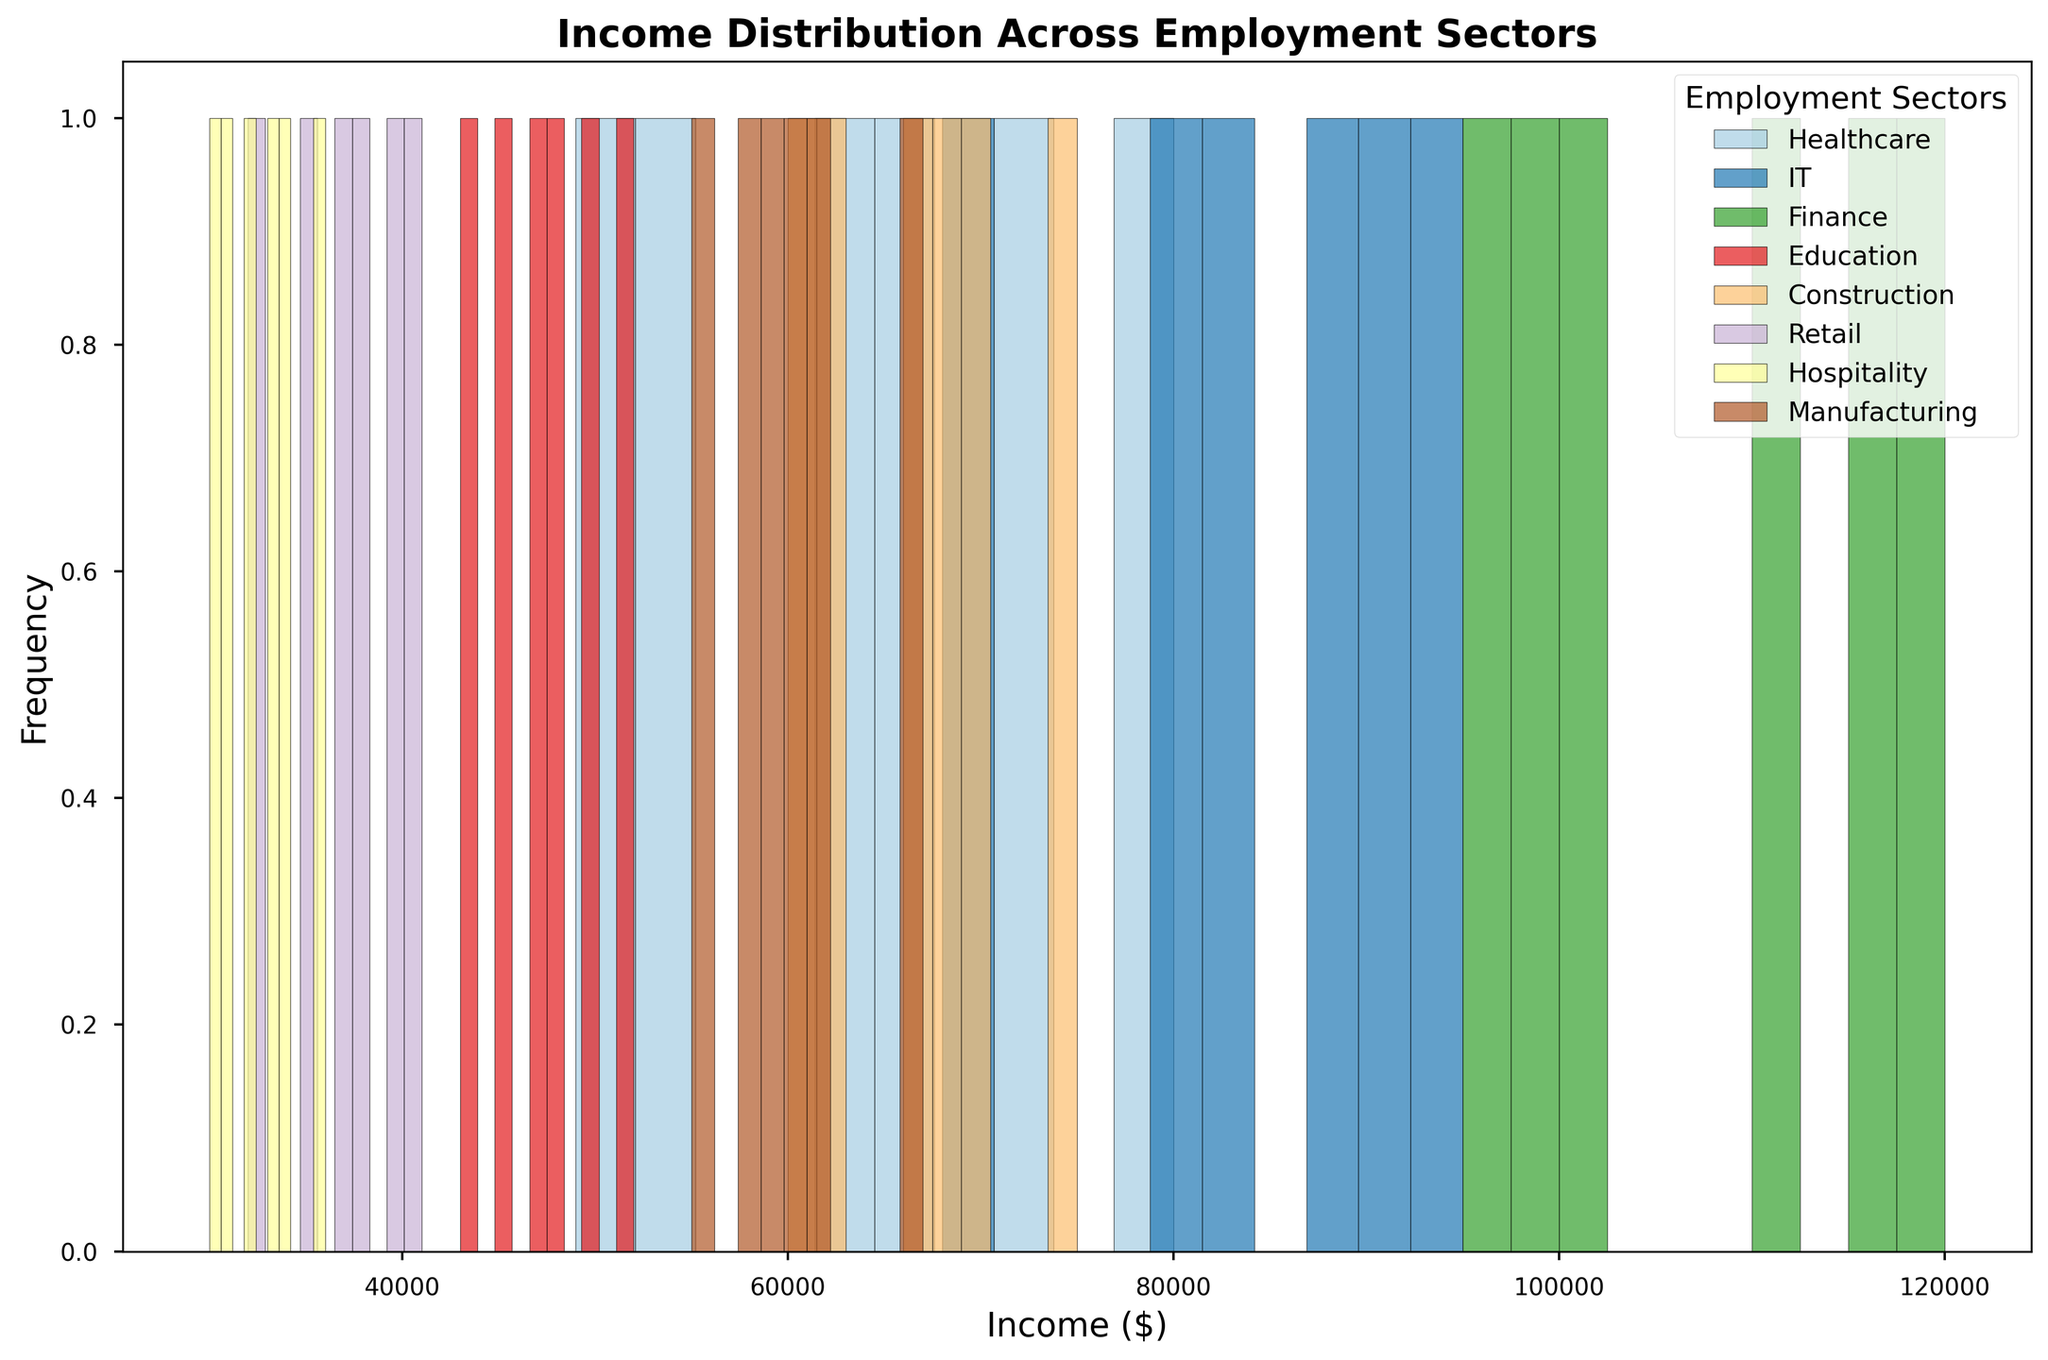Which employment sector shows the broadest range of income distribution? Identify the spread of the histogram bins for each sector and see which sector spans the most income ranges. Sectors like Finance and IT show a wider range compared to others like Hospitality and Retail. Therefore, Finance and IT have the broadest income distribution.
Answer: Finance and IT Which sector has the highest peak frequency in the histogram? Identify the tallest bar in the histograms. The sector with the highest peak indicates the sector with the most frequency at a particular income level. The highest peak frequency is in the Retail sector.
Answer: Retail How does the income distribution in the Healthcare sector compare to the IT sector in terms of spread? Observe the range of incomes for both sectors. Healthcare has its spread from around 49,000 to 80,000, while IT has a wider spread from around 68,000 to 95,000. Therefore, IT has a wider income distribution spread compared to Healthcare.
Answer: IT has a wider spread Which sector has the least variation in income distribution? Look for the sector with the narrowest or least spread in the histogram. The Hospitality sector appears to have the narrowest income distribution among all the sectors.
Answer: Hospitality What is the common income range for the Education sector? Identify where most of the frequency lies within the Education sector histogram. The income range predominantly lies between 43,000 and 52,000.
Answer: 43,000-52,000 Are there any sectors where the income distribution overlaps entirely with another sector? Compare the income ranges for all sectors. The Retail and Hospitality sectors overlap almost entirely within the range of around 30,000 to 41,000.
Answer: Retail and Hospitality Which color is used to represent the Finance sector in the histogram? Identify the color corresponding to the label "Finance" in the legend of the histogram. The Finance sector is represented by a specific color shaded in the histogram bars.
Answer: The color used in the plot What is the range of incomes for the Manufacturing sector? Look at the histogram bins for the Manufacturing sector to determine the lowest and highest income levels. The range spans from 55,000 to 67,000.
Answer: 55,000-67,000 Is the peak frequency of the Construction sector higher than the peak of the Healthcare sector? Compare the tallest histogram bar in the Construction sector to the tallest in the Healthcare sector. Yes, Construction's peak frequency is higher than that of Healthcare.
Answer: Yes 